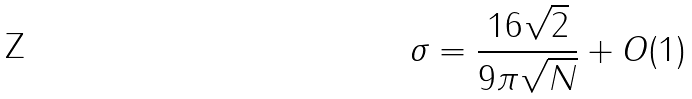Convert formula to latex. <formula><loc_0><loc_0><loc_500><loc_500>\sigma = \frac { 1 6 \sqrt { 2 } } { 9 \pi \sqrt { N } } + O ( 1 )</formula> 